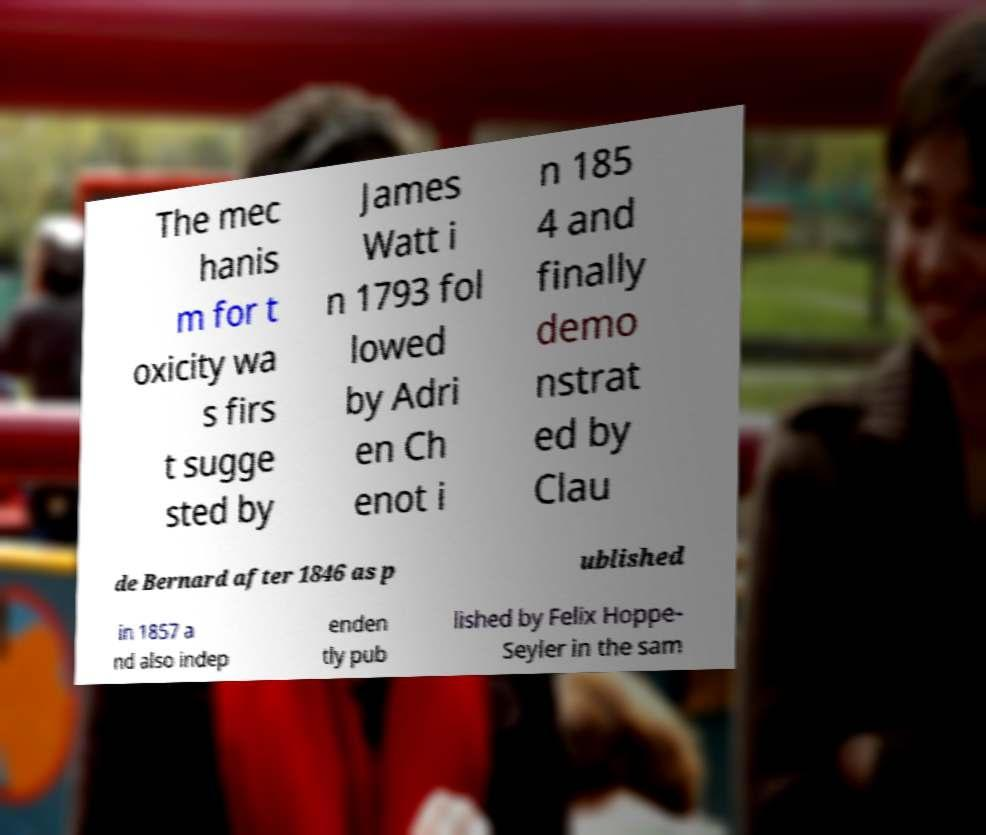Could you assist in decoding the text presented in this image and type it out clearly? The mec hanis m for t oxicity wa s firs t sugge sted by James Watt i n 1793 fol lowed by Adri en Ch enot i n 185 4 and finally demo nstrat ed by Clau de Bernard after 1846 as p ublished in 1857 a nd also indep enden tly pub lished by Felix Hoppe- Seyler in the sam 